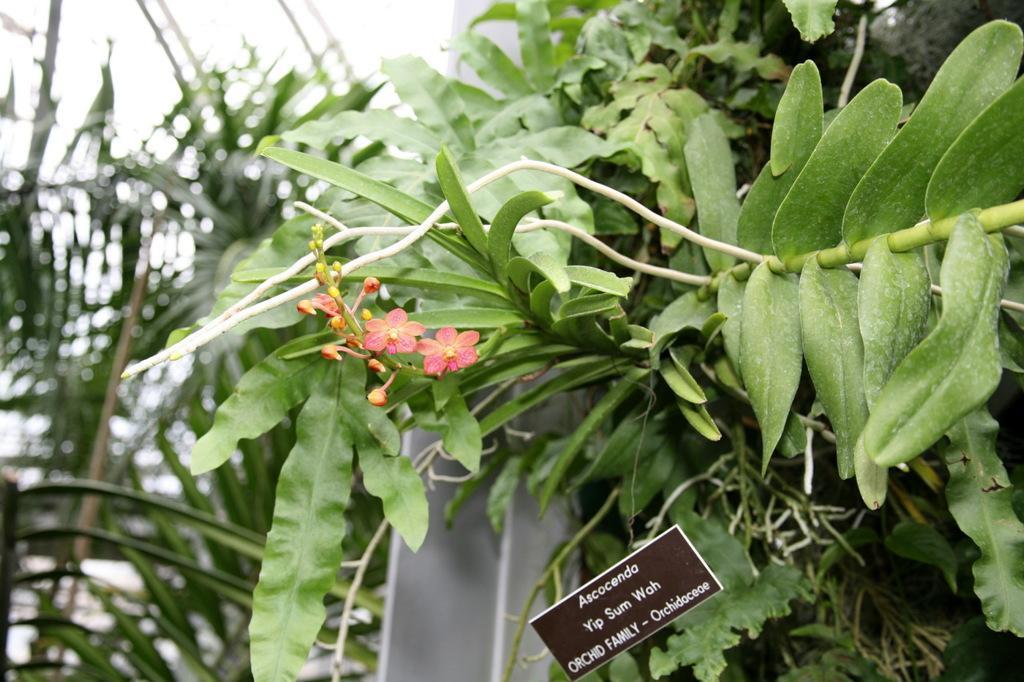Describe this image in one or two sentences. In this picture, we see the trees. In the middle, we see the flower and the buds in pink and orange color. At the bottom, we see a small black color board with some text written on it. In the middle, we see the white poles. There are trees in the background. At the top, we see the sky. This picture is blurred in the background. 